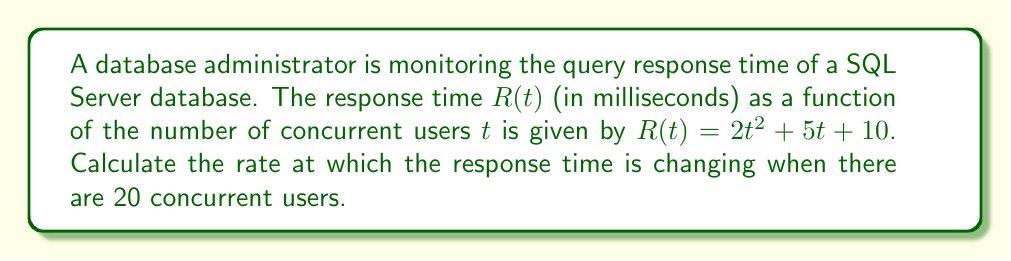Give your solution to this math problem. To find the rate of change in the response time with respect to the number of concurrent users, we need to calculate the derivative of $R(t)$ and then evaluate it at $t = 20$.

Step 1: Find the derivative of $R(t)$
$$R(t) = 2t^2 + 5t + 10$$
$$\frac{dR}{dt} = 4t + 5$$

Step 2: Evaluate the derivative at $t = 20$
$$\frac{dR}{dt}\bigg|_{t=20} = 4(20) + 5$$
$$= 80 + 5 = 85$$

The rate of change is 85 milliseconds per user when there are 20 concurrent users.
Answer: 85 ms/user 